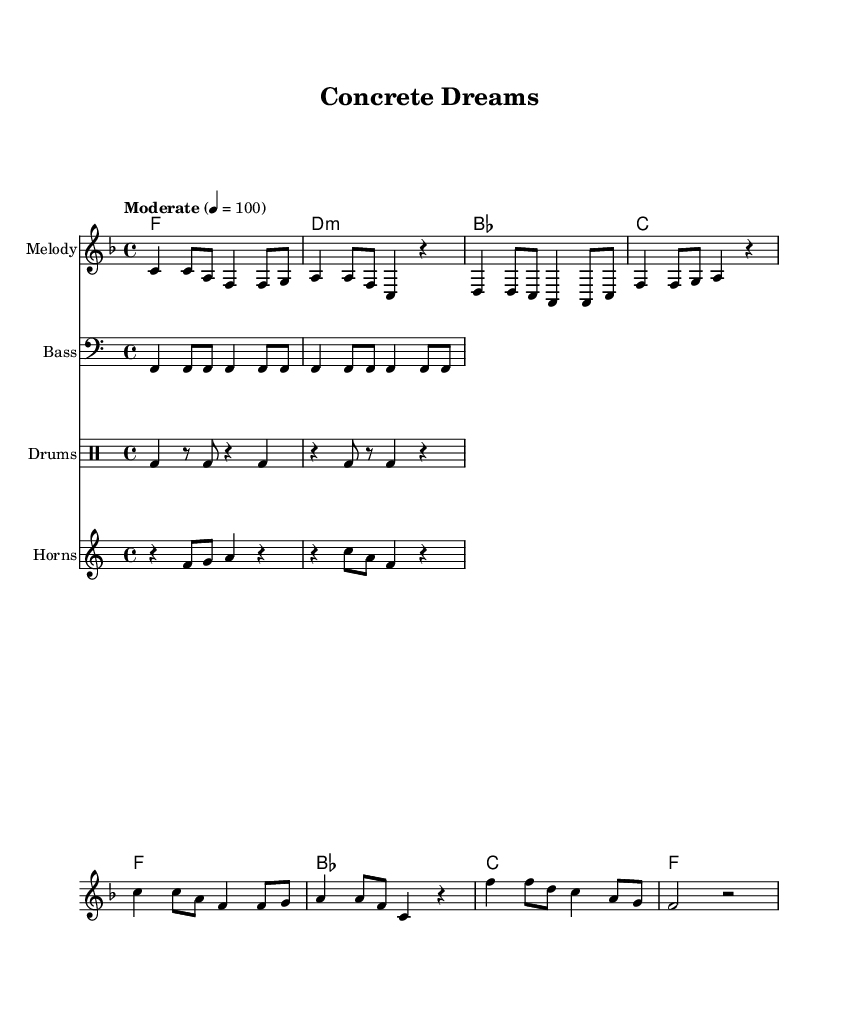What is the key signature of this music? The key signature is F major, indicated by one flat (B flat) in the notation. This is determined by looking at the global section of the code where it states "\key f \major."
Answer: F major What is the time signature of this music? The time signature is 4/4, which is common time. This can be found in the global section of the code, specifically indicated by "\time 4/4."
Answer: 4/4 What is the tempo marking of this music? The tempo marking indicates "Moderate" at a tempo of quarter note = 100 beats per minute, which informs the performer to play at a moderate pace. This is explicitly stated in the global section with "\tempo 'Moderate' 4 = 100."
Answer: Moderate 100 How many measures are in the melody? There are 8 measures total in the melody. This can be determined by counting the groups of notes separated by the bar lines in the melody section.
Answer: 8 What is the main theme of the lyrics? The main theme of the lyrics is urban renewal and hope for the future as articulated in phrases like "a city's dream is coming true" and "building futures." This understanding comes from analyzing the verses and the chorus which repeatedly refers to dreams and growth.
Answer: Urban renewal What is the structure of the song? The structure consists of verses followed by a chorus, as indicated in the code. The lyrics have explicit sections labeled "verseOne" and "chorus," showing a common verse-chorus structure typical in soul music.
Answer: Verse-Chorus What instruments are featured in this score? The instruments featured include melody, bass, horns, and drums, as noted in the new staff sections for each. This is visible in the score with named instrument groups: "Melody," "Bass," "Horns," and "Drums."
Answer: Melody, Bass, Horns, Drums 